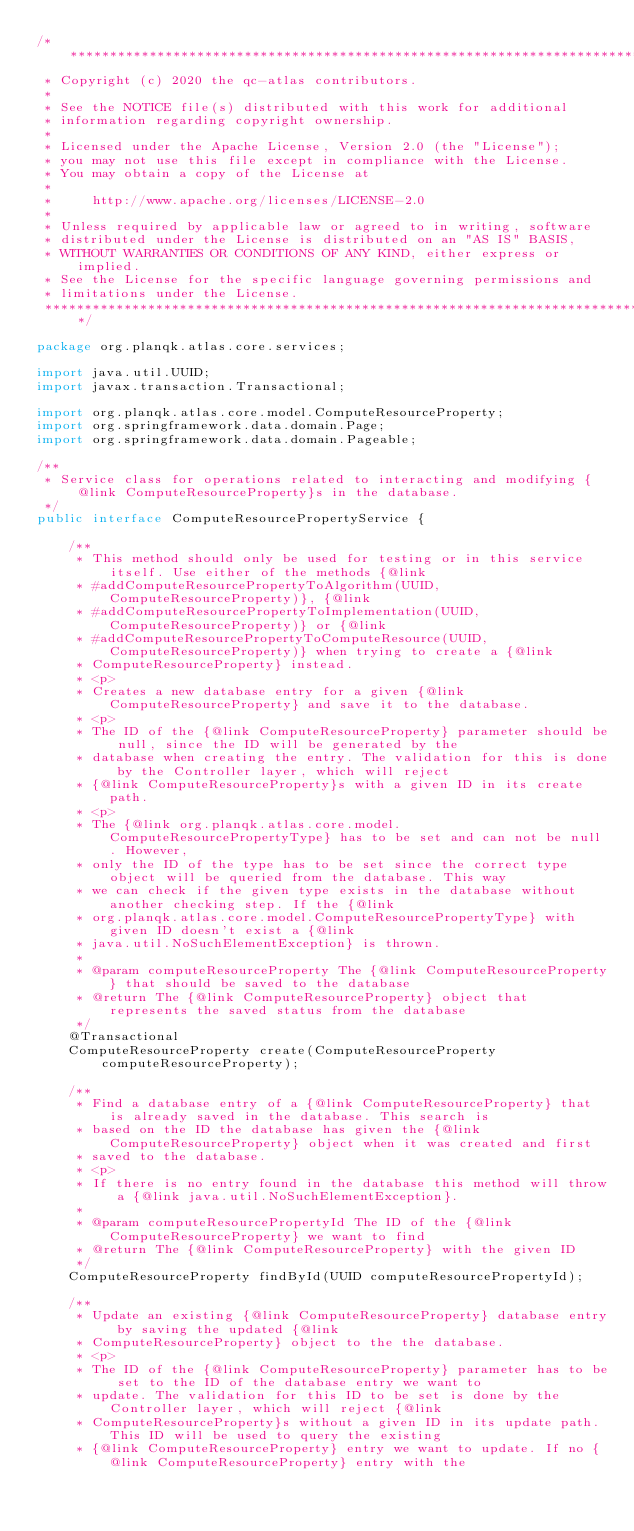<code> <loc_0><loc_0><loc_500><loc_500><_Java_>/*******************************************************************************
 * Copyright (c) 2020 the qc-atlas contributors.
 *
 * See the NOTICE file(s) distributed with this work for additional
 * information regarding copyright ownership.
 *
 * Licensed under the Apache License, Version 2.0 (the "License");
 * you may not use this file except in compliance with the License.
 * You may obtain a copy of the License at
 *
 *     http://www.apache.org/licenses/LICENSE-2.0
 *
 * Unless required by applicable law or agreed to in writing, software
 * distributed under the License is distributed on an "AS IS" BASIS,
 * WITHOUT WARRANTIES OR CONDITIONS OF ANY KIND, either express or implied.
 * See the License for the specific language governing permissions and
 * limitations under the License.
 *******************************************************************************/

package org.planqk.atlas.core.services;

import java.util.UUID;
import javax.transaction.Transactional;

import org.planqk.atlas.core.model.ComputeResourceProperty;
import org.springframework.data.domain.Page;
import org.springframework.data.domain.Pageable;

/**
 * Service class for operations related to interacting and modifying {@link ComputeResourceProperty}s in the database.
 */
public interface ComputeResourcePropertyService {

    /**
     * This method should only be used for testing or in this service itself. Use either of the methods {@link
     * #addComputeResourcePropertyToAlgorithm(UUID, ComputeResourceProperty)}, {@link
     * #addComputeResourcePropertyToImplementation(UUID, ComputeResourceProperty)} or {@link
     * #addComputeResourcePropertyToComputeResource(UUID, ComputeResourceProperty)} when trying to create a {@link
     * ComputeResourceProperty} instead.
     * <p>
     * Creates a new database entry for a given {@link ComputeResourceProperty} and save it to the database.
     * <p>
     * The ID of the {@link ComputeResourceProperty} parameter should be null, since the ID will be generated by the
     * database when creating the entry. The validation for this is done by the Controller layer, which will reject
     * {@link ComputeResourceProperty}s with a given ID in its create path.
     * <p>
     * The {@link org.planqk.atlas.core.model.ComputeResourcePropertyType} has to be set and can not be null. However,
     * only the ID of the type has to be set since the correct type object will be queried from the database. This way
     * we can check if the given type exists in the database without another checking step. If the {@link
     * org.planqk.atlas.core.model.ComputeResourcePropertyType} with given ID doesn't exist a {@link
     * java.util.NoSuchElementException} is thrown.
     *
     * @param computeResourceProperty The {@link ComputeResourceProperty} that should be saved to the database
     * @return The {@link ComputeResourceProperty} object that represents the saved status from the database
     */
    @Transactional
    ComputeResourceProperty create(ComputeResourceProperty computeResourceProperty);

    /**
     * Find a database entry of a {@link ComputeResourceProperty} that is already saved in the database. This search is
     * based on the ID the database has given the {@link ComputeResourceProperty} object when it was created and first
     * saved to the database.
     * <p>
     * If there is no entry found in the database this method will throw a {@link java.util.NoSuchElementException}.
     *
     * @param computeResourcePropertyId The ID of the {@link ComputeResourceProperty} we want to find
     * @return The {@link ComputeResourceProperty} with the given ID
     */
    ComputeResourceProperty findById(UUID computeResourcePropertyId);

    /**
     * Update an existing {@link ComputeResourceProperty} database entry by saving the updated {@link
     * ComputeResourceProperty} object to the the database.
     * <p>
     * The ID of the {@link ComputeResourceProperty} parameter has to be set to the ID of the database entry we want to
     * update. The validation for this ID to be set is done by the Controller layer, which will reject {@link
     * ComputeResourceProperty}s without a given ID in its update path. This ID will be used to query the existing
     * {@link ComputeResourceProperty} entry we want to update. If no {@link ComputeResourceProperty} entry with the</code> 